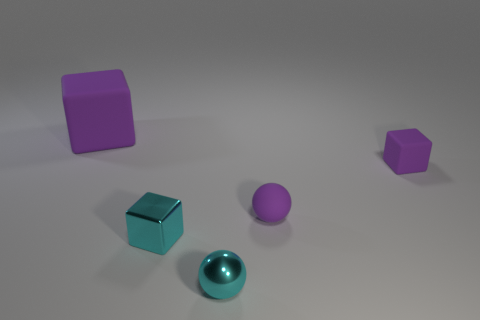What number of cyan things are metallic objects or small things?
Your answer should be very brief. 2. There is a cube that is both on the left side of the tiny purple sphere and in front of the big purple matte object; what is its color?
Give a very brief answer. Cyan. Do the small sphere in front of the tiny purple rubber sphere and the purple cube that is on the left side of the small shiny cube have the same material?
Your answer should be compact. No. Is the number of metallic objects that are to the left of the small cyan ball greater than the number of tiny spheres on the right side of the purple sphere?
Provide a short and direct response. Yes. The metallic object that is the same size as the metal sphere is what shape?
Your answer should be very brief. Cube. What number of things are metallic cylinders or cyan metallic objects that are in front of the small cyan cube?
Offer a very short reply. 1. Does the large cube have the same color as the small rubber ball?
Ensure brevity in your answer.  Yes. What number of tiny matte things are in front of the small purple block?
Your answer should be compact. 1. The big thing that is the same material as the purple sphere is what color?
Keep it short and to the point. Purple. What number of rubber objects are either tiny brown spheres or blocks?
Offer a very short reply. 2. 